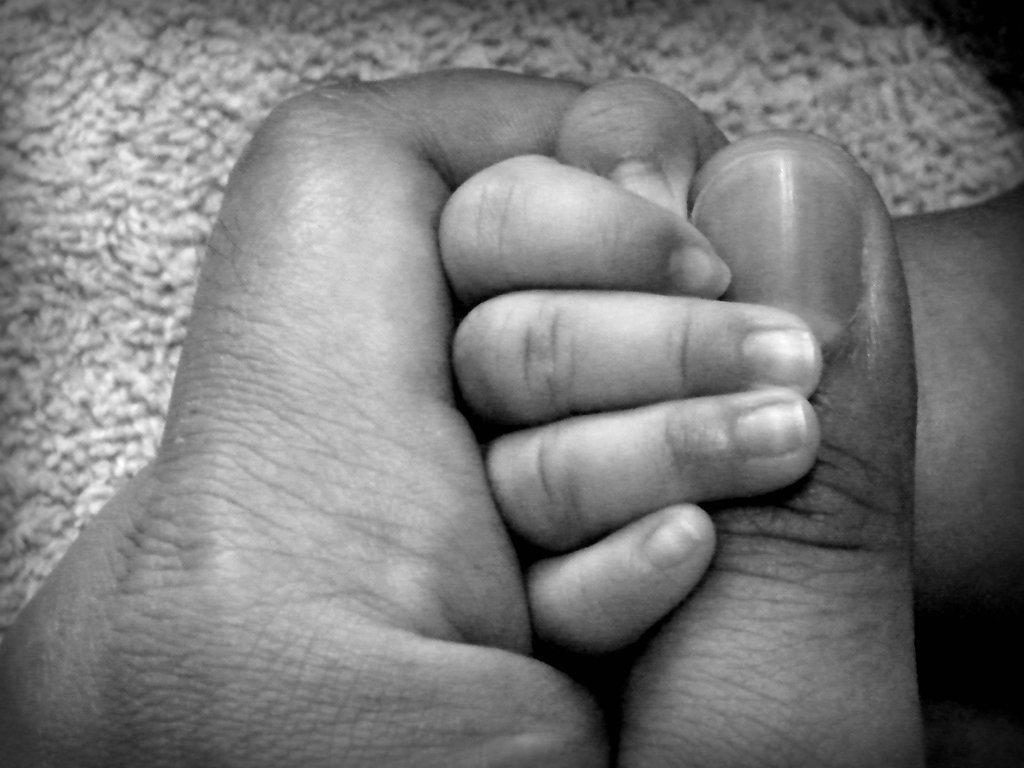Could you give a brief overview of what you see in this image? In this picture I can see there is a person holding a infant's hand and in the backdrop there is a carpet and this is a black and white image. 